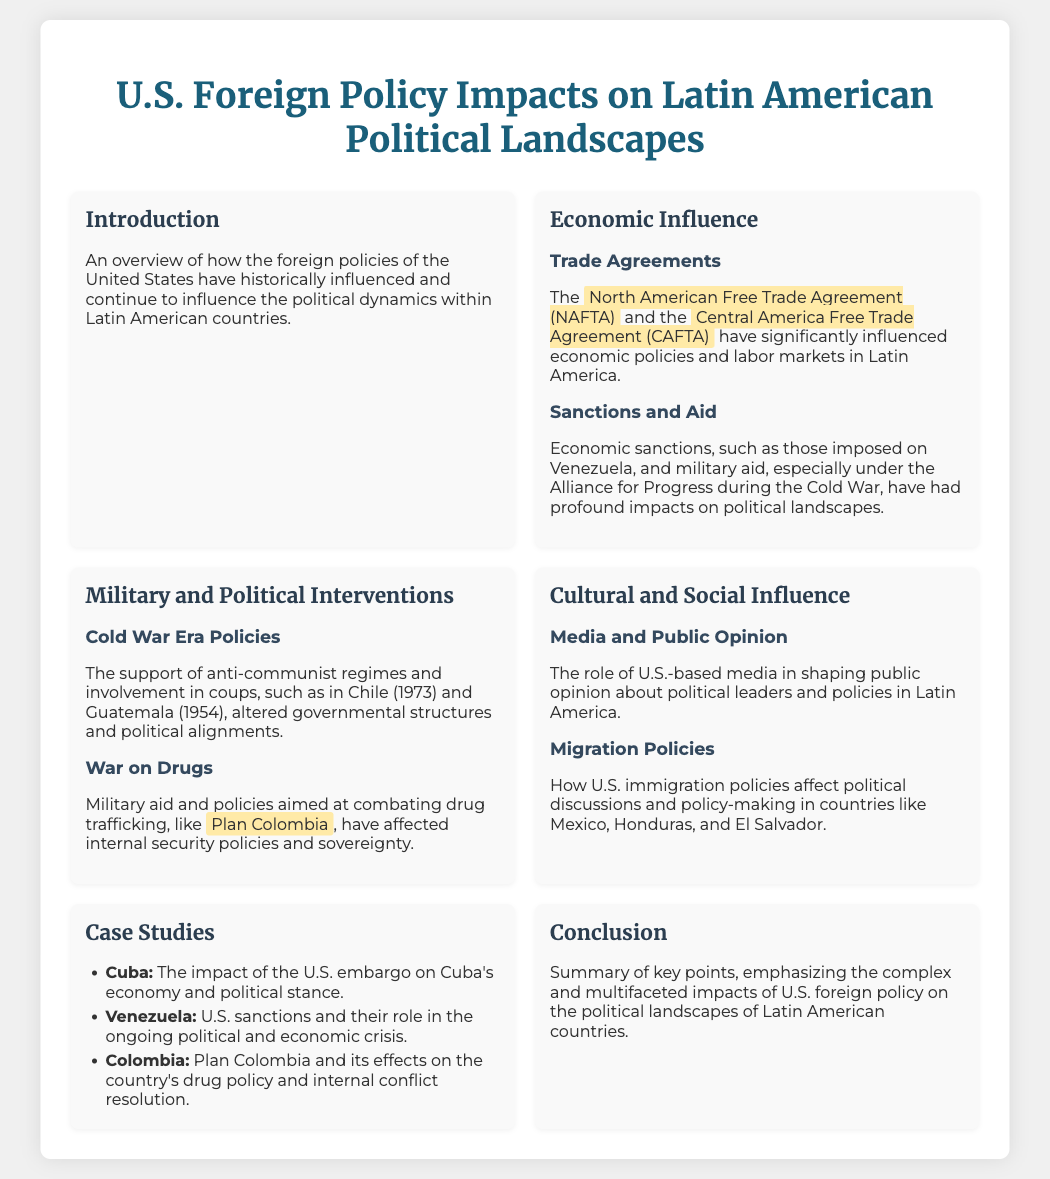What is the title of the presentation? The title is presented at the top of the slide, introducing the main topic.
Answer: U.S. Foreign Policy Impacts on Latin American Political Landscapes Which trade agreements are mentioned? The slide lists specific trade agreements that influence economic policies in Latin America.
Answer: North American Free Trade Agreement (NAFTA) and Central America Free Trade Agreement (CAFTA) What period is associated with military and political interventions? This section discusses interventions during a notable historical period impacting Latin American politics.
Answer: Cold War Era What is the focus of the case study about Venezuela? The slide specifically addresses a pivotal issue regarding U.S. actions in Venezuela's crisis.
Answer: U.S. sanctions and their role in the ongoing political and economic crisis What impact does media have according to the presentation? This highlights the influence media has on public perception in Latin America.
Answer: Shaping public opinion about political leaders and policies How many case studies are listed in the document? The presentation enumerates specific examples under the case studies section.
Answer: Three 